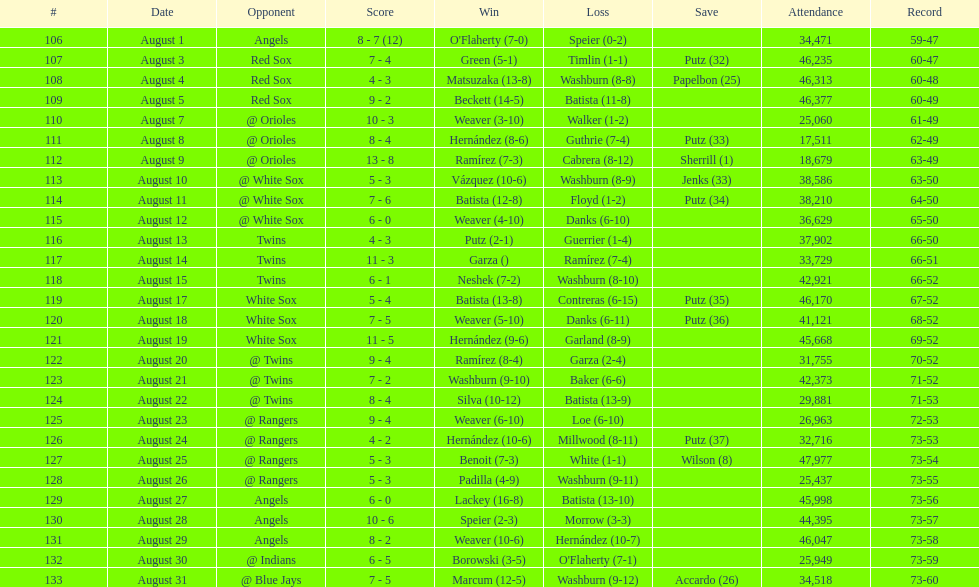Can you list the games with an audience exceeding 30,000 attendees? 21. 